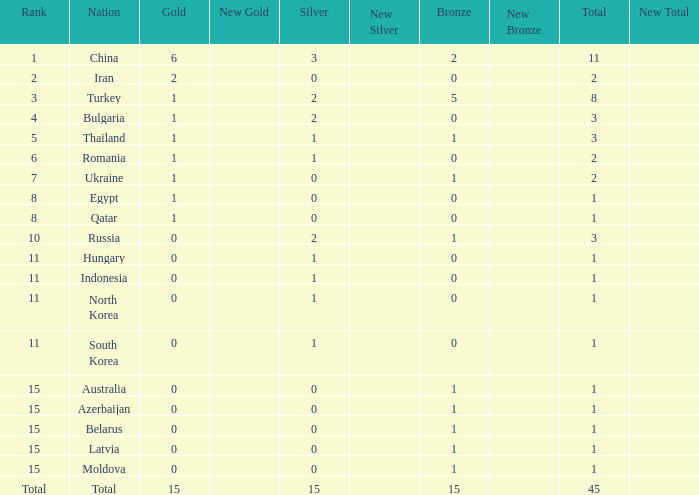What is the sum of the bronze medals of the nation with less than 0 silvers? None. 